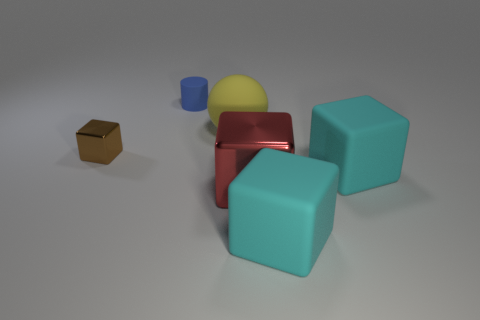Subtract all red cubes. How many cubes are left? 3 Subtract all brown spheres. How many cyan blocks are left? 2 Add 4 small rubber things. How many objects exist? 10 Subtract 1 blocks. How many blocks are left? 3 Subtract all red blocks. How many blocks are left? 3 Subtract all cylinders. How many objects are left? 5 Subtract all gray blocks. Subtract all brown spheres. How many blocks are left? 4 Add 2 large green rubber cylinders. How many large green rubber cylinders exist? 2 Subtract 0 green cubes. How many objects are left? 6 Subtract all brown metal objects. Subtract all large yellow rubber objects. How many objects are left? 4 